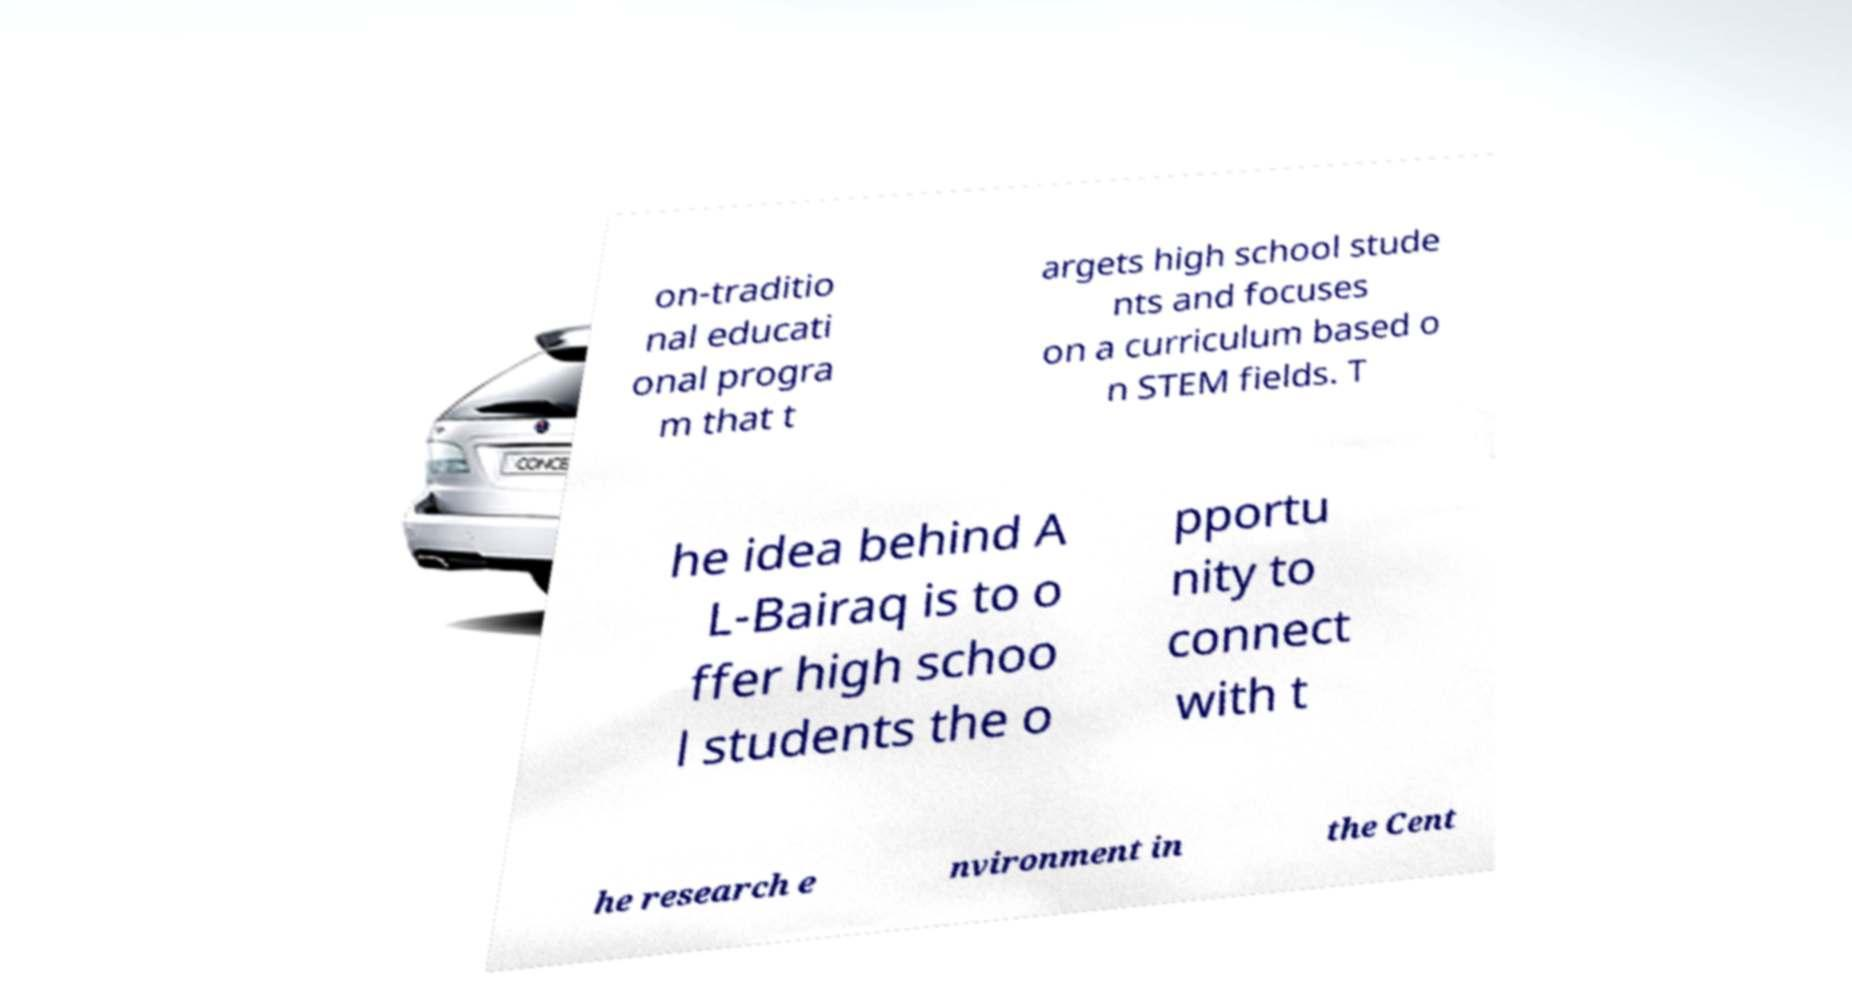Could you assist in decoding the text presented in this image and type it out clearly? on-traditio nal educati onal progra m that t argets high school stude nts and focuses on a curriculum based o n STEM fields. T he idea behind A L-Bairaq is to o ffer high schoo l students the o pportu nity to connect with t he research e nvironment in the Cent 